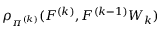Convert formula to latex. <formula><loc_0><loc_0><loc_500><loc_500>\rho _ { \pi ^ { ( k ) } } ( F ^ { ( k ) } , F ^ { ( k - 1 ) } W _ { k } )</formula> 